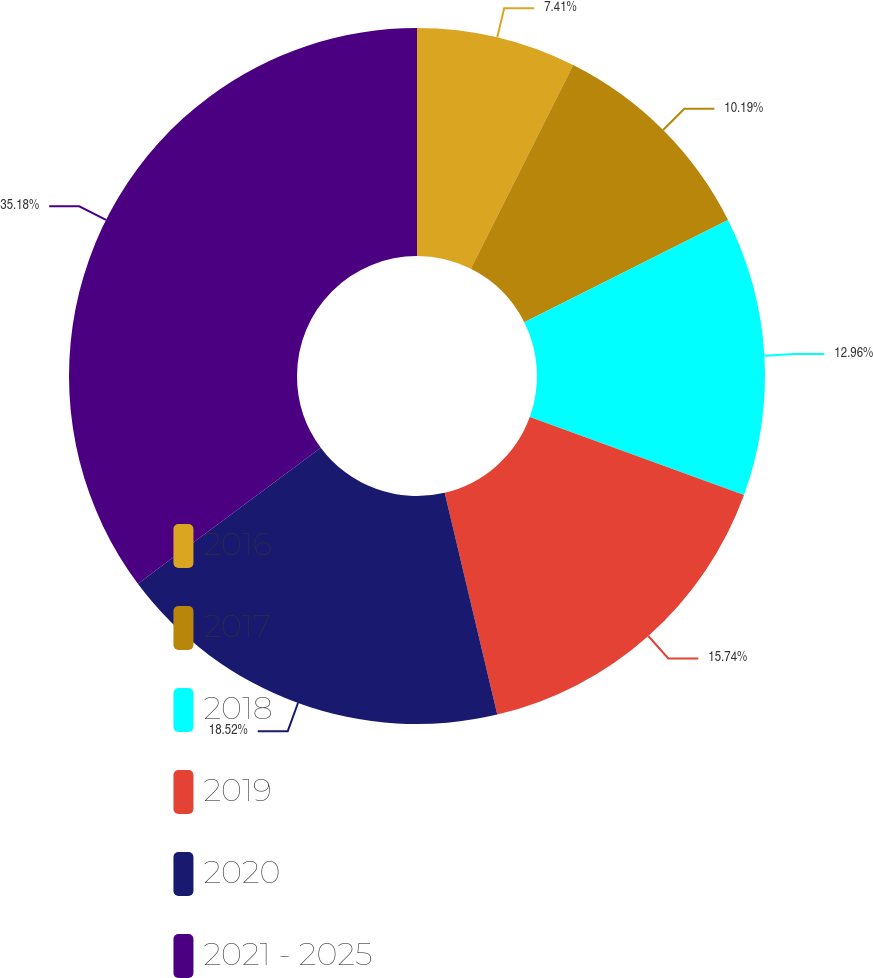Convert chart. <chart><loc_0><loc_0><loc_500><loc_500><pie_chart><fcel>2016<fcel>2017<fcel>2018<fcel>2019<fcel>2020<fcel>2021 - 2025<nl><fcel>7.41%<fcel>10.19%<fcel>12.96%<fcel>15.74%<fcel>18.52%<fcel>35.19%<nl></chart> 